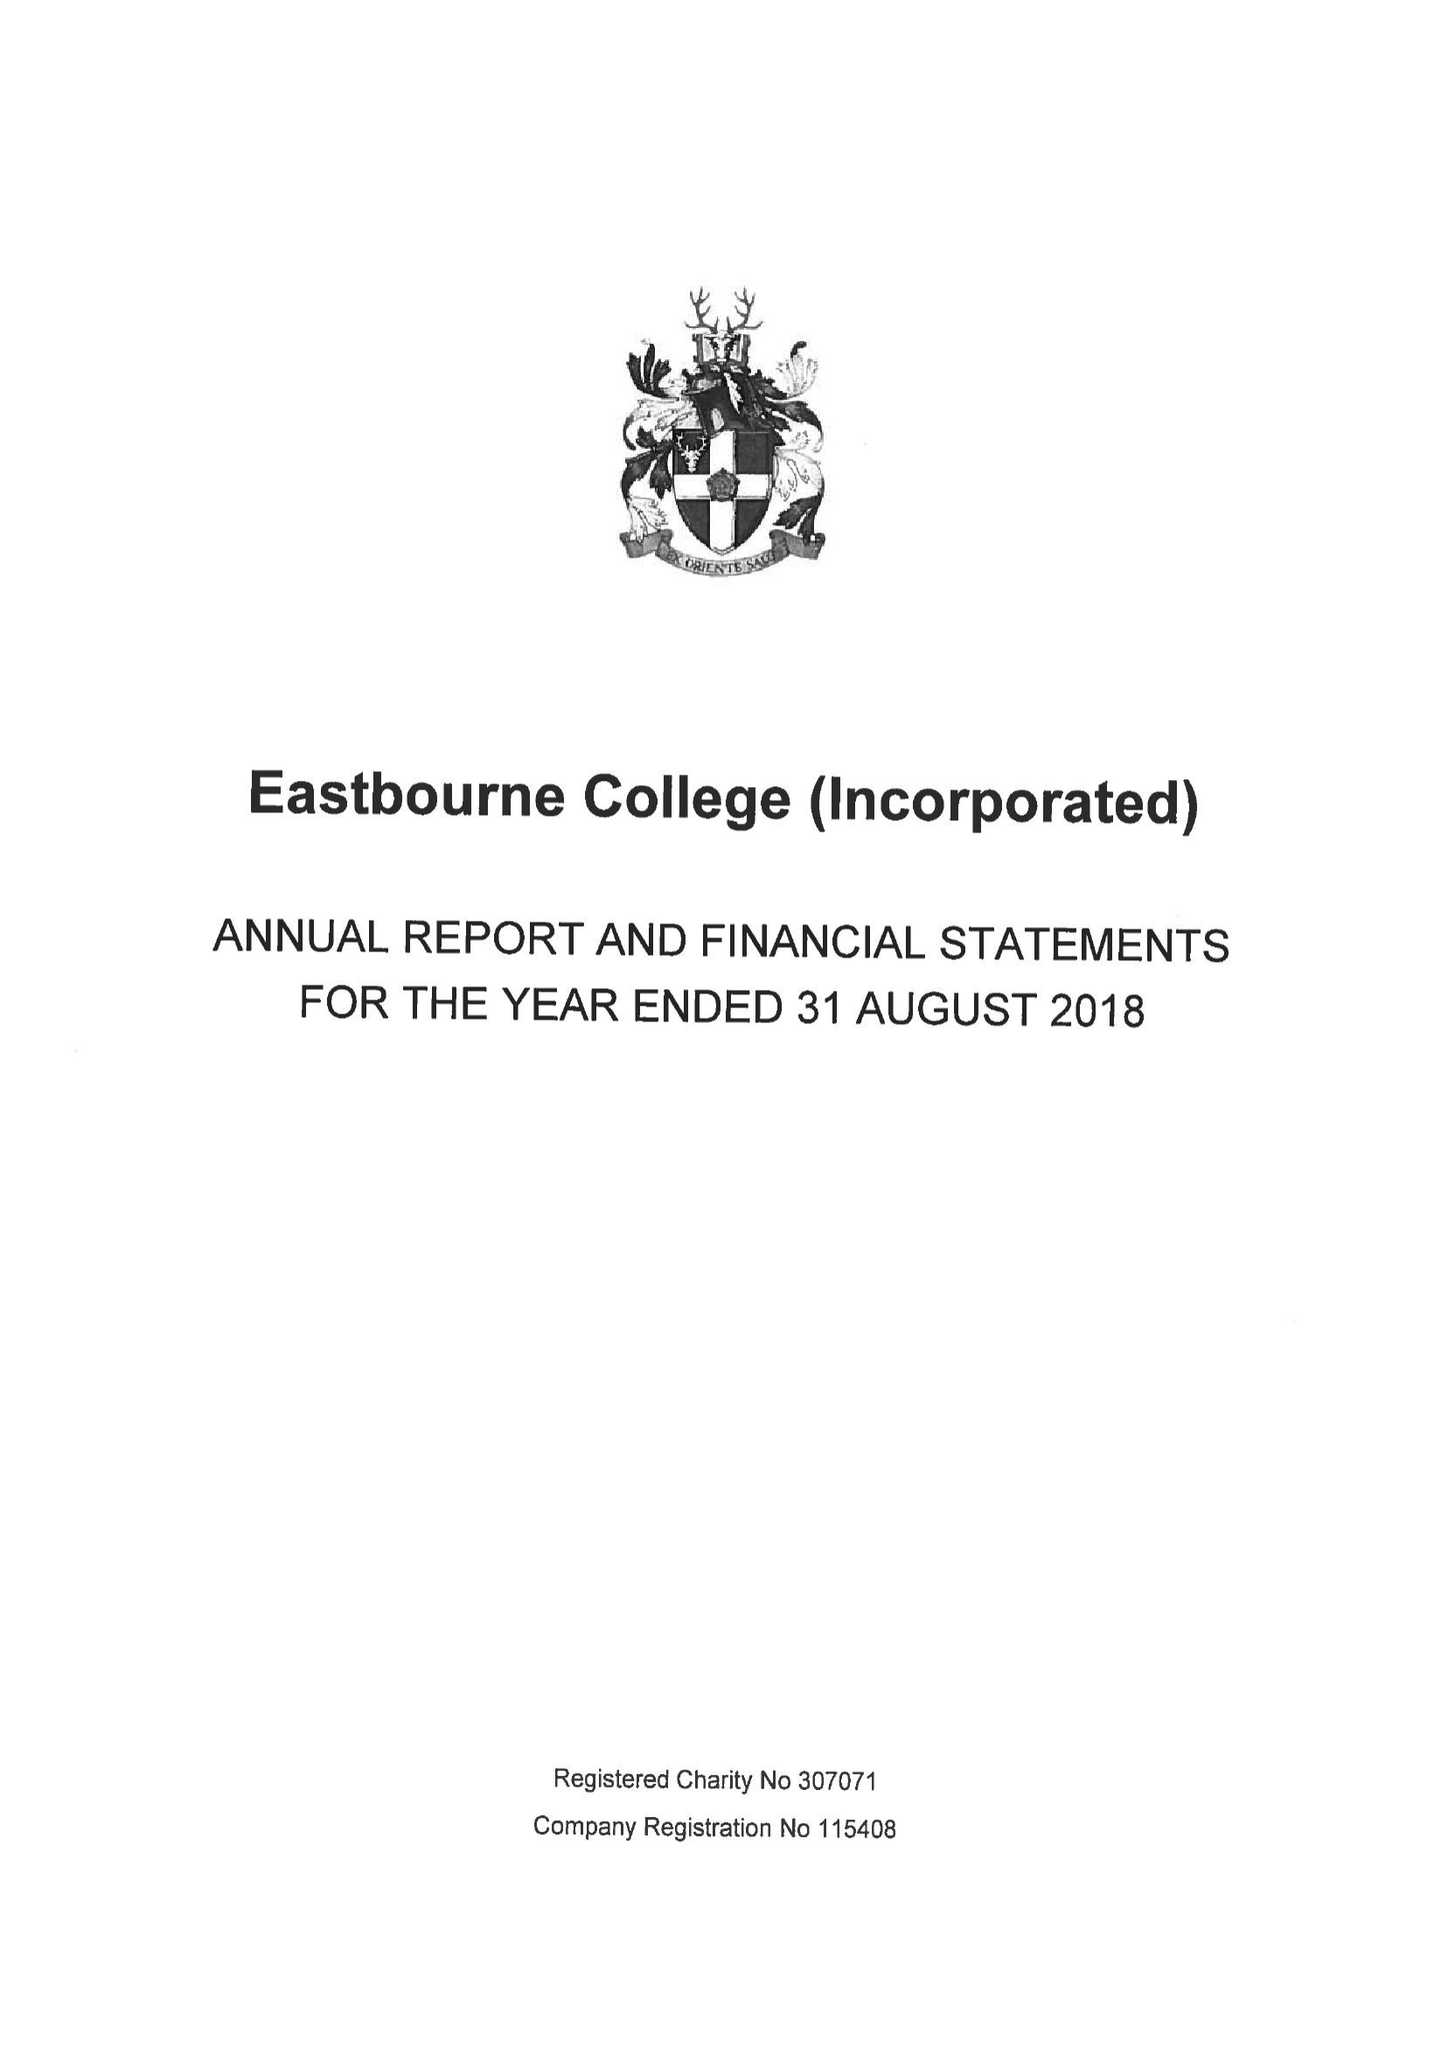What is the value for the charity_name?
Answer the question using a single word or phrase. Eastbourne College (Incorporated) 